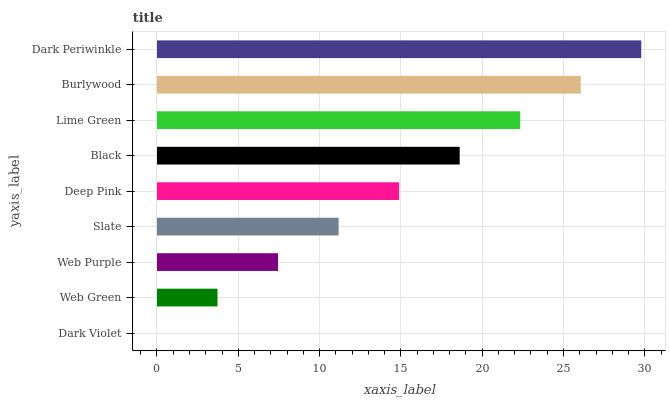Is Dark Violet the minimum?
Answer yes or no. Yes. Is Dark Periwinkle the maximum?
Answer yes or no. Yes. Is Web Green the minimum?
Answer yes or no. No. Is Web Green the maximum?
Answer yes or no. No. Is Web Green greater than Dark Violet?
Answer yes or no. Yes. Is Dark Violet less than Web Green?
Answer yes or no. Yes. Is Dark Violet greater than Web Green?
Answer yes or no. No. Is Web Green less than Dark Violet?
Answer yes or no. No. Is Deep Pink the high median?
Answer yes or no. Yes. Is Deep Pink the low median?
Answer yes or no. Yes. Is Web Green the high median?
Answer yes or no. No. Is Dark Periwinkle the low median?
Answer yes or no. No. 